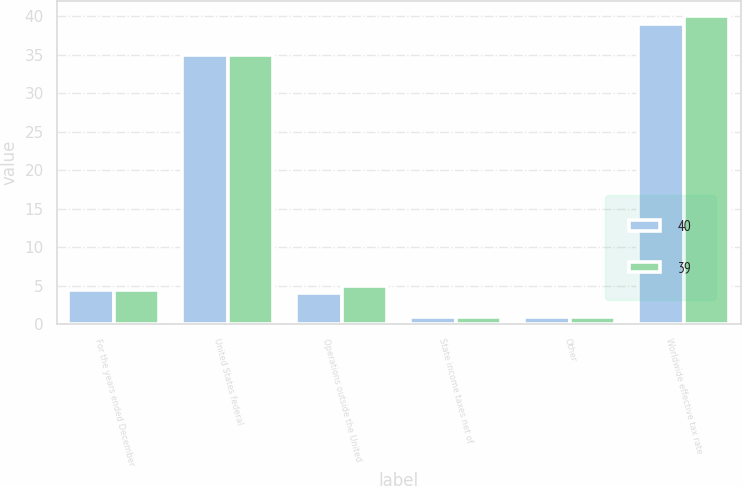<chart> <loc_0><loc_0><loc_500><loc_500><stacked_bar_chart><ecel><fcel>For the years ended December<fcel>United States federal<fcel>Operations outside the United<fcel>State income taxes net of<fcel>Other<fcel>Worldwide effective tax rate<nl><fcel>40<fcel>4.5<fcel>35<fcel>4<fcel>1<fcel>1<fcel>39<nl><fcel>39<fcel>4.5<fcel>35<fcel>5<fcel>1<fcel>1<fcel>40<nl></chart> 